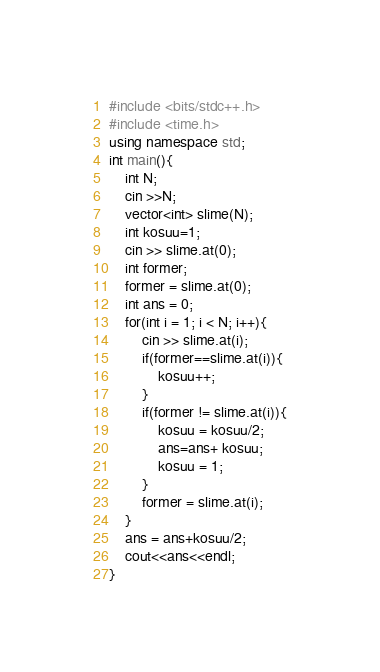<code> <loc_0><loc_0><loc_500><loc_500><_C++_>#include <bits/stdc++.h>
#include <time.h>
using namespace std;
int main(){
    int N;
    cin >>N;
    vector<int> slime(N);
    int kosuu=1;
    cin >> slime.at(0);
    int former;
    former = slime.at(0);
    int ans = 0;
    for(int i = 1; i < N; i++){
        cin >> slime.at(i);
        if(former==slime.at(i)){
            kosuu++;
        }
        if(former != slime.at(i)){
            kosuu = kosuu/2;
            ans=ans+ kosuu;
            kosuu = 1;
        }
        former = slime.at(i);
    }
    ans = ans+kosuu/2;
    cout<<ans<<endl;
}</code> 